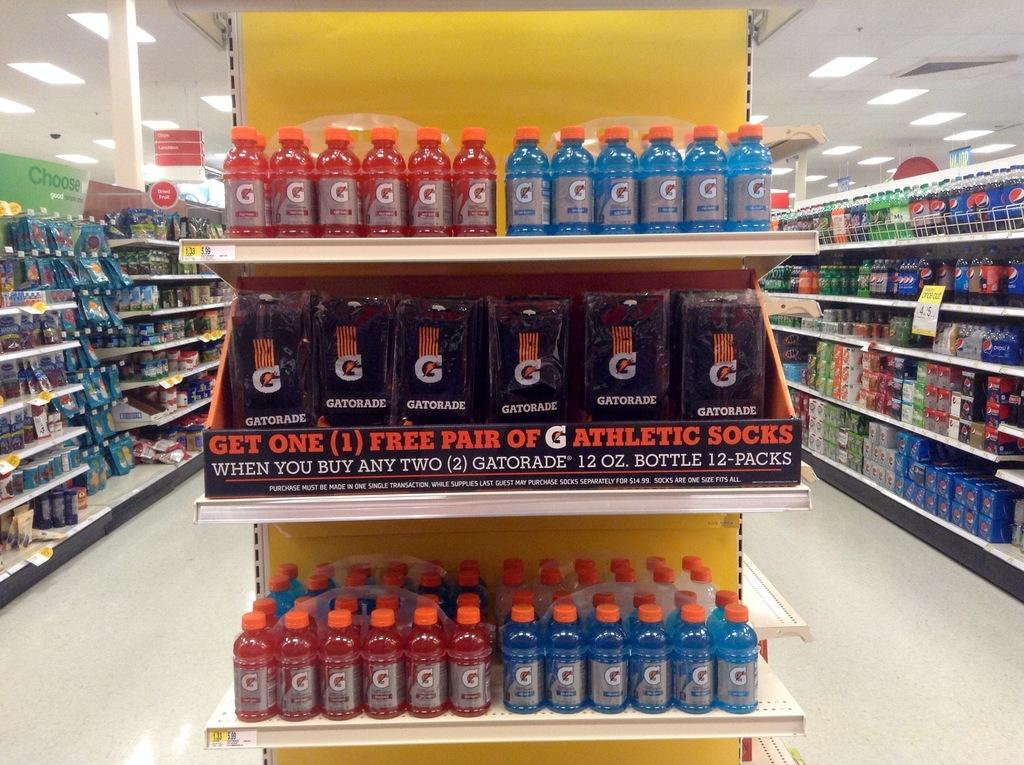<image>
Write a terse but informative summary of the picture. A supermarket with a shelf display reading: "Get One (1) Free Pair of G Athletic socks." 